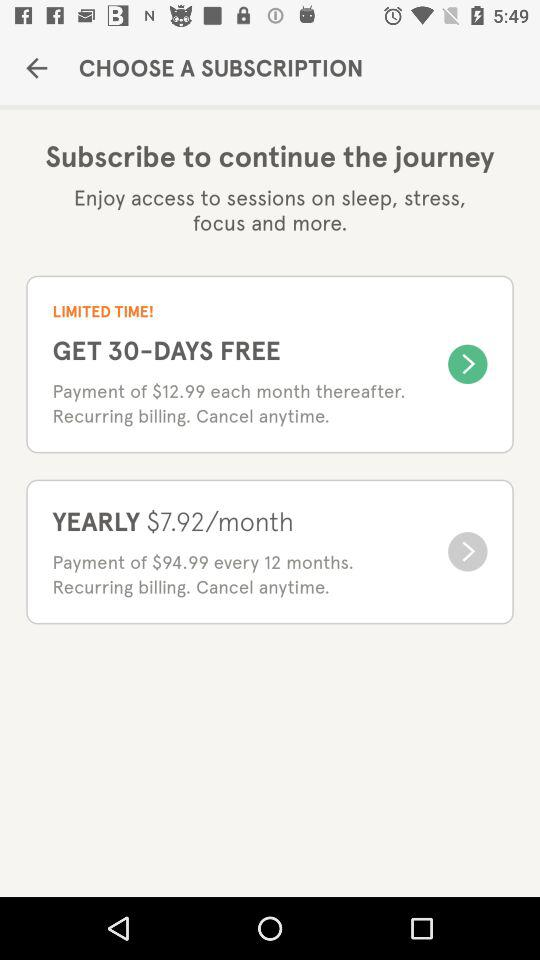What is the per month cost? The per month cost is $12.99. 